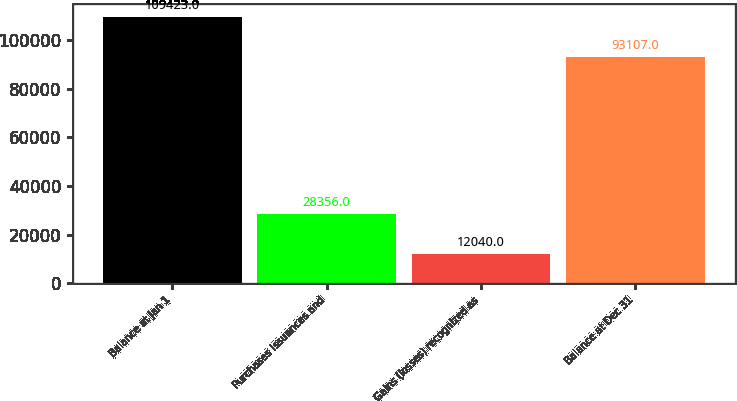Convert chart. <chart><loc_0><loc_0><loc_500><loc_500><bar_chart><fcel>Balance at Jan 1<fcel>Purchases issuances and<fcel>Gains (losses) recognized as<fcel>Balance at Dec 31<nl><fcel>109423<fcel>28356<fcel>12040<fcel>93107<nl></chart> 